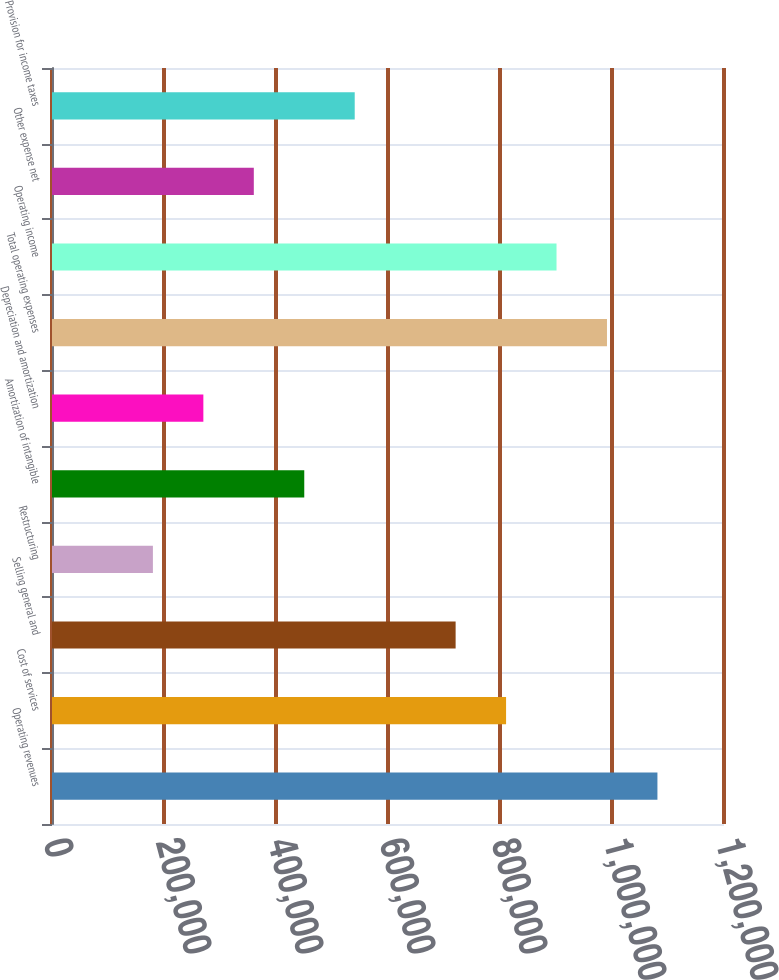Convert chart. <chart><loc_0><loc_0><loc_500><loc_500><bar_chart><fcel>Operating revenues<fcel>Cost of services<fcel>Selling general and<fcel>Restructuring<fcel>Amortization of intangible<fcel>Depreciation and amortization<fcel>Total operating expenses<fcel>Operating income<fcel>Other expense net<fcel>Provision for income taxes<nl><fcel>1.08113e+06<fcel>810847<fcel>720753<fcel>180189<fcel>450471<fcel>270283<fcel>991035<fcel>900941<fcel>360377<fcel>540565<nl></chart> 